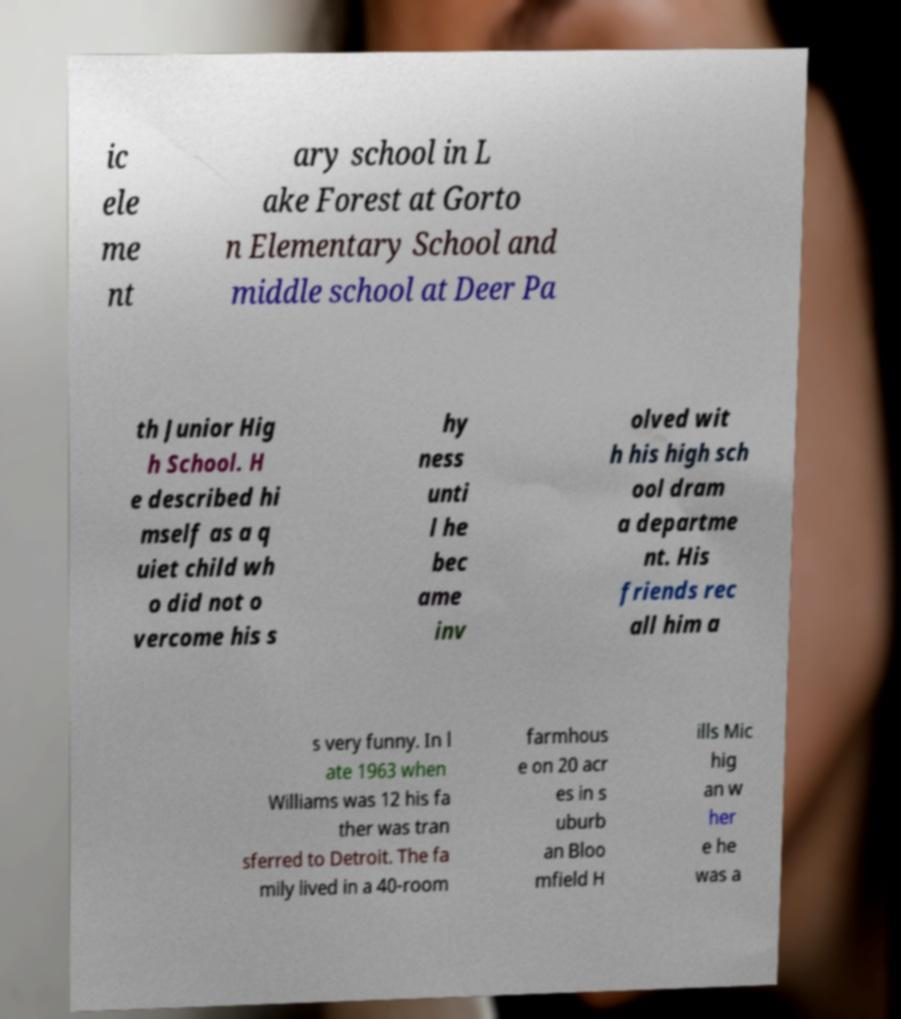Could you extract and type out the text from this image? ic ele me nt ary school in L ake Forest at Gorto n Elementary School and middle school at Deer Pa th Junior Hig h School. H e described hi mself as a q uiet child wh o did not o vercome his s hy ness unti l he bec ame inv olved wit h his high sch ool dram a departme nt. His friends rec all him a s very funny. In l ate 1963 when Williams was 12 his fa ther was tran sferred to Detroit. The fa mily lived in a 40-room farmhous e on 20 acr es in s uburb an Bloo mfield H ills Mic hig an w her e he was a 